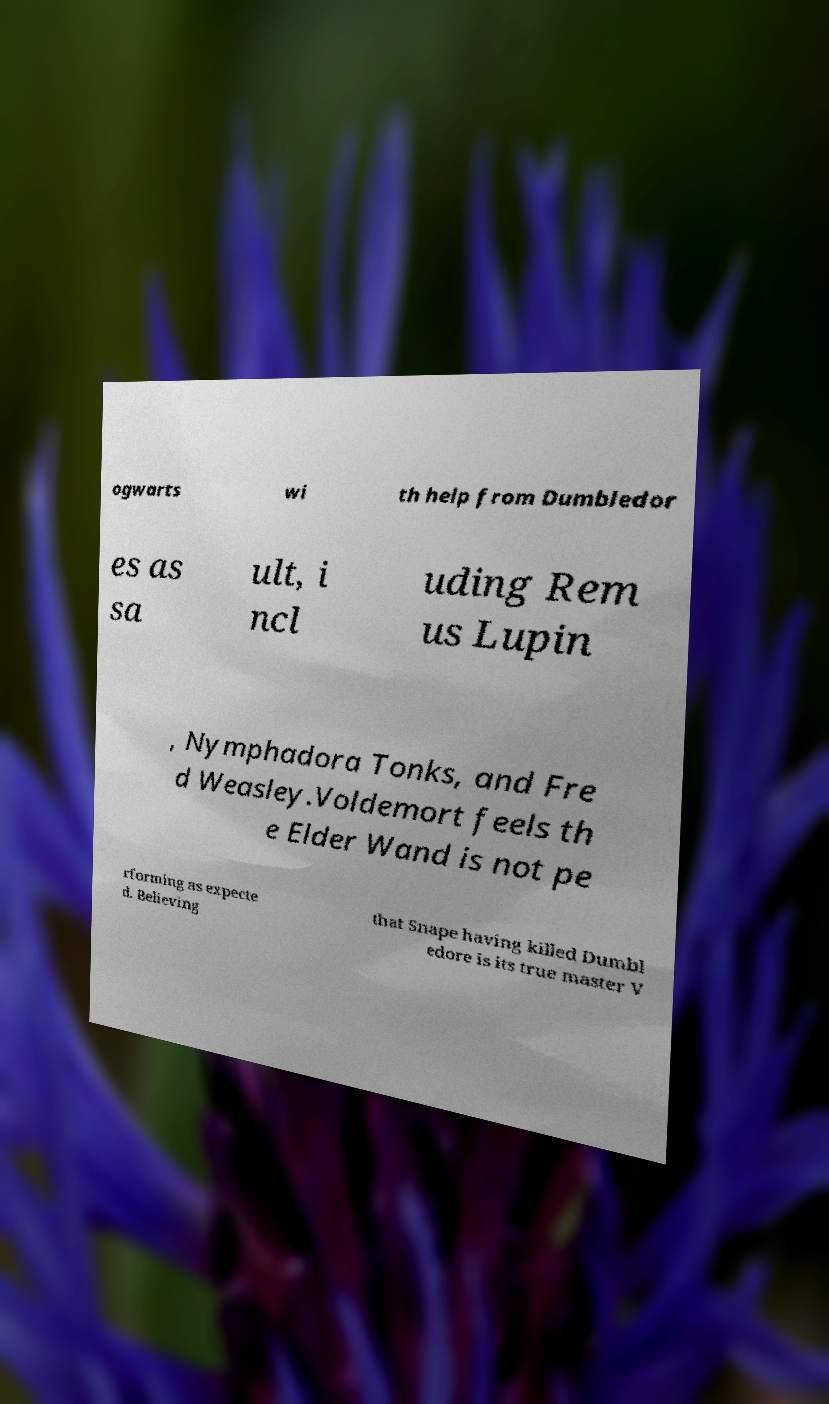For documentation purposes, I need the text within this image transcribed. Could you provide that? ogwarts wi th help from Dumbledor es as sa ult, i ncl uding Rem us Lupin , Nymphadora Tonks, and Fre d Weasley.Voldemort feels th e Elder Wand is not pe rforming as expecte d. Believing that Snape having killed Dumbl edore is its true master V 